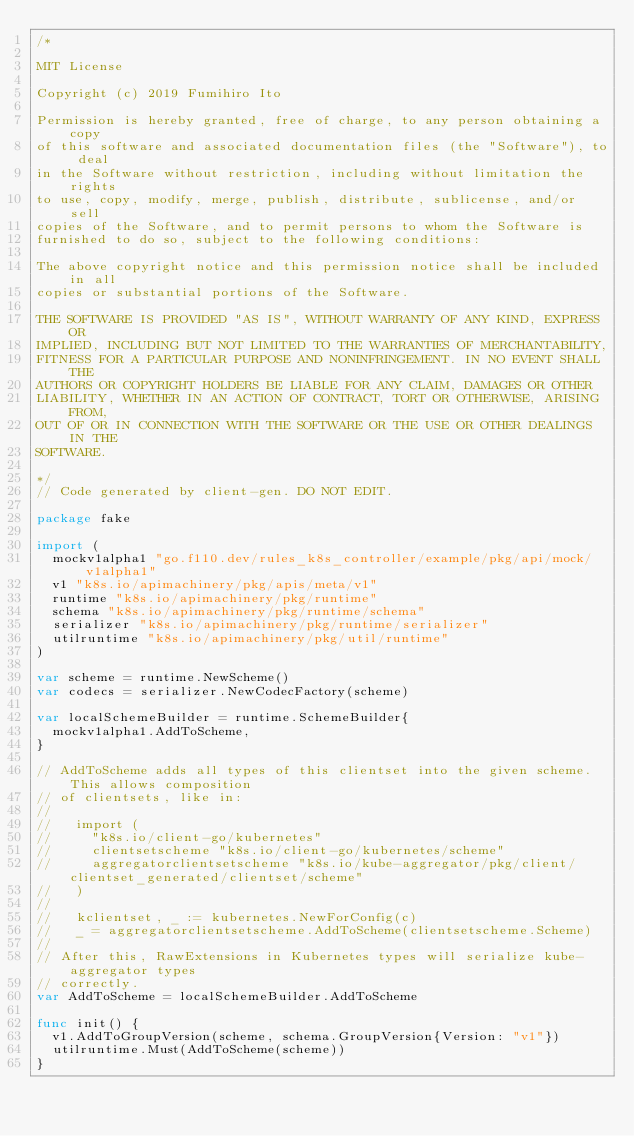Convert code to text. <code><loc_0><loc_0><loc_500><loc_500><_Go_>/*

MIT License

Copyright (c) 2019 Fumihiro Ito

Permission is hereby granted, free of charge, to any person obtaining a copy
of this software and associated documentation files (the "Software"), to deal
in the Software without restriction, including without limitation the rights
to use, copy, modify, merge, publish, distribute, sublicense, and/or sell
copies of the Software, and to permit persons to whom the Software is
furnished to do so, subject to the following conditions:

The above copyright notice and this permission notice shall be included in all
copies or substantial portions of the Software.

THE SOFTWARE IS PROVIDED "AS IS", WITHOUT WARRANTY OF ANY KIND, EXPRESS OR
IMPLIED, INCLUDING BUT NOT LIMITED TO THE WARRANTIES OF MERCHANTABILITY,
FITNESS FOR A PARTICULAR PURPOSE AND NONINFRINGEMENT. IN NO EVENT SHALL THE
AUTHORS OR COPYRIGHT HOLDERS BE LIABLE FOR ANY CLAIM, DAMAGES OR OTHER
LIABILITY, WHETHER IN AN ACTION OF CONTRACT, TORT OR OTHERWISE, ARISING FROM,
OUT OF OR IN CONNECTION WITH THE SOFTWARE OR THE USE OR OTHER DEALINGS IN THE
SOFTWARE.

*/
// Code generated by client-gen. DO NOT EDIT.

package fake

import (
	mockv1alpha1 "go.f110.dev/rules_k8s_controller/example/pkg/api/mock/v1alpha1"
	v1 "k8s.io/apimachinery/pkg/apis/meta/v1"
	runtime "k8s.io/apimachinery/pkg/runtime"
	schema "k8s.io/apimachinery/pkg/runtime/schema"
	serializer "k8s.io/apimachinery/pkg/runtime/serializer"
	utilruntime "k8s.io/apimachinery/pkg/util/runtime"
)

var scheme = runtime.NewScheme()
var codecs = serializer.NewCodecFactory(scheme)

var localSchemeBuilder = runtime.SchemeBuilder{
	mockv1alpha1.AddToScheme,
}

// AddToScheme adds all types of this clientset into the given scheme. This allows composition
// of clientsets, like in:
//
//   import (
//     "k8s.io/client-go/kubernetes"
//     clientsetscheme "k8s.io/client-go/kubernetes/scheme"
//     aggregatorclientsetscheme "k8s.io/kube-aggregator/pkg/client/clientset_generated/clientset/scheme"
//   )
//
//   kclientset, _ := kubernetes.NewForConfig(c)
//   _ = aggregatorclientsetscheme.AddToScheme(clientsetscheme.Scheme)
//
// After this, RawExtensions in Kubernetes types will serialize kube-aggregator types
// correctly.
var AddToScheme = localSchemeBuilder.AddToScheme

func init() {
	v1.AddToGroupVersion(scheme, schema.GroupVersion{Version: "v1"})
	utilruntime.Must(AddToScheme(scheme))
}
</code> 